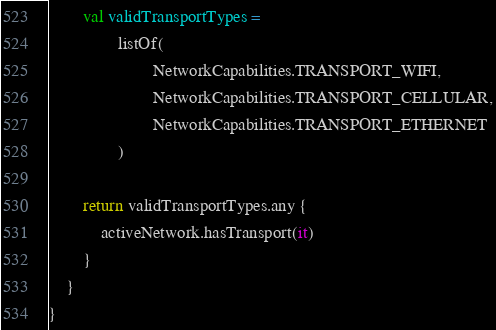Convert code to text. <code><loc_0><loc_0><loc_500><loc_500><_Kotlin_>        val validTransportTypes =
                listOf(
                        NetworkCapabilities.TRANSPORT_WIFI,
                        NetworkCapabilities.TRANSPORT_CELLULAR,
                        NetworkCapabilities.TRANSPORT_ETHERNET
                )

        return validTransportTypes.any {
            activeNetwork.hasTransport(it)
        }
    }
}</code> 